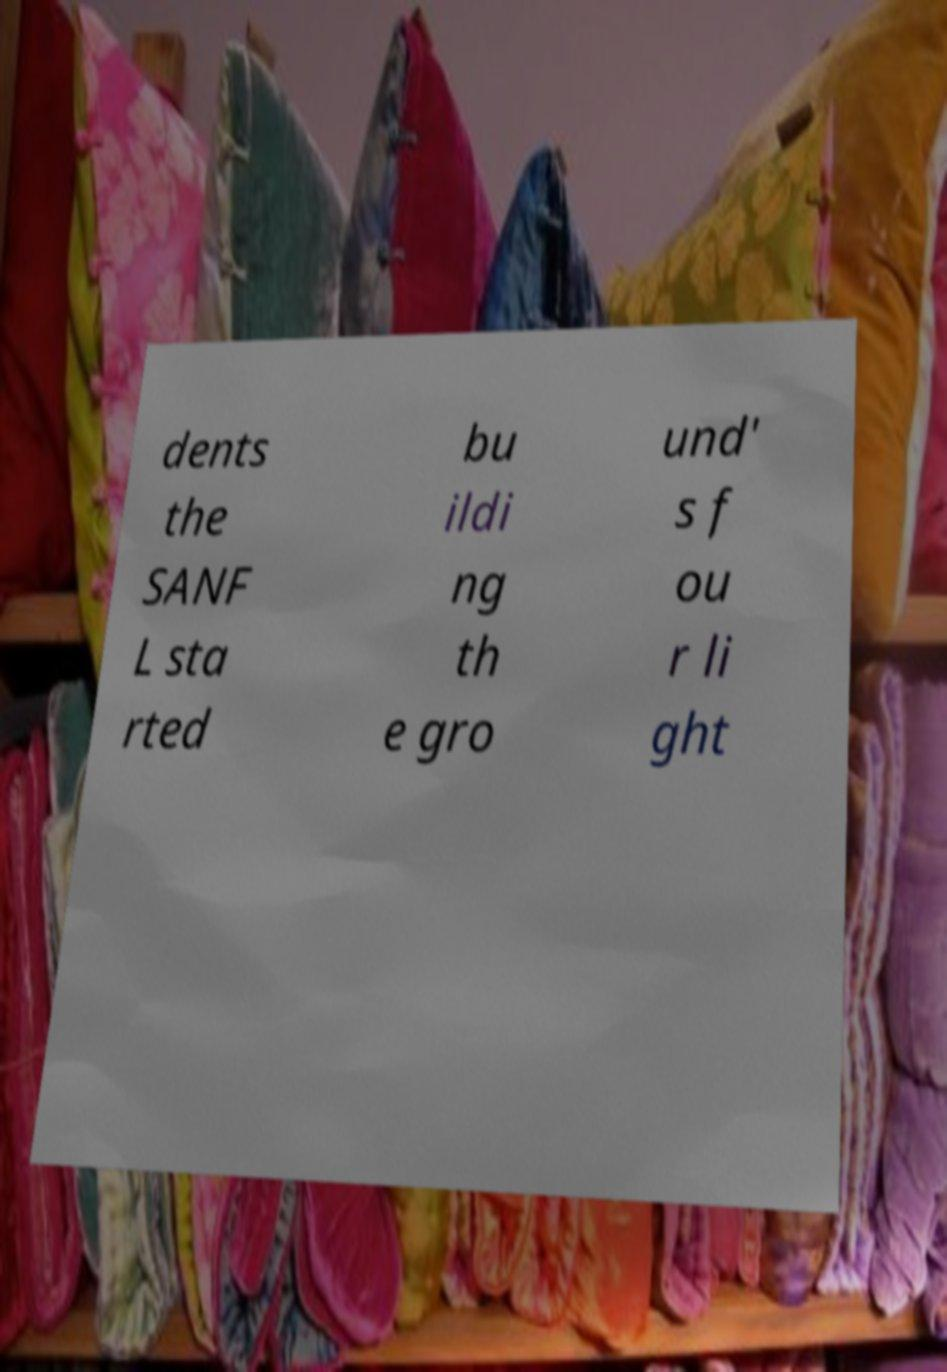There's text embedded in this image that I need extracted. Can you transcribe it verbatim? dents the SANF L sta rted bu ildi ng th e gro und' s f ou r li ght 